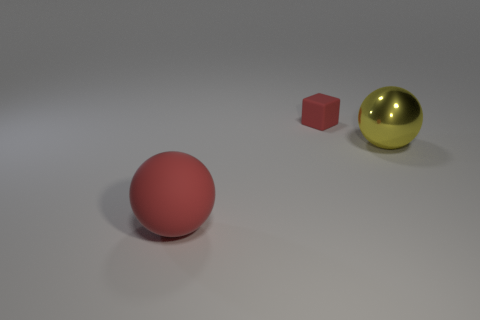Add 1 big cyan blocks. How many objects exist? 4 Subtract all balls. How many objects are left? 1 Subtract 0 purple blocks. How many objects are left? 3 Subtract all tiny brown rubber cylinders. Subtract all big red balls. How many objects are left? 2 Add 2 cubes. How many cubes are left? 3 Add 3 tiny cyan metallic spheres. How many tiny cyan metallic spheres exist? 3 